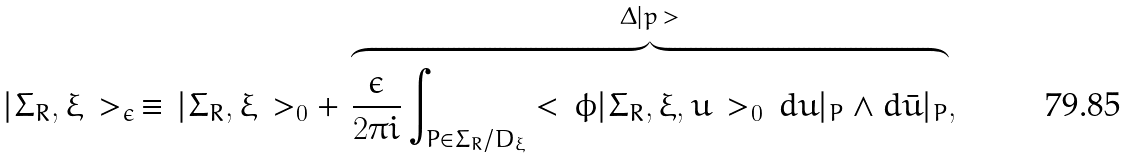Convert formula to latex. <formula><loc_0><loc_0><loc_500><loc_500>| \Sigma _ { R } , \xi \, > _ { \epsilon } \, \equiv \, | \Sigma _ { R } , \xi \, > _ { 0 } + \, \overbrace { \frac { \epsilon } { 2 \pi i } \int _ { P \in \Sigma _ { R } / D _ { \xi } } < \, \phi | \Sigma _ { R } , \xi , u \, > _ { 0 } \, d u | _ { P } \wedge d \bar { u } | _ { P } } ^ { \Delta | p \, > } ,</formula> 